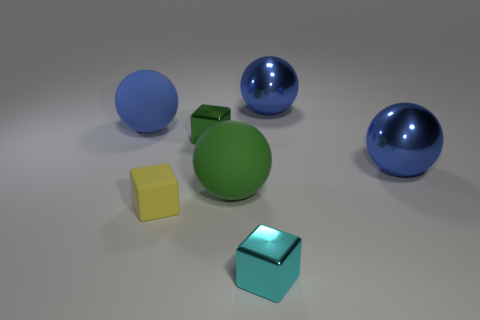There is a blue metallic sphere that is in front of the blue sphere to the left of the cube right of the big green thing; what size is it?
Your answer should be compact. Large. Is the number of green metallic cubes to the right of the small green metal thing greater than the number of tiny cyan blocks?
Make the answer very short. No. Are any tiny cyan metallic things visible?
Ensure brevity in your answer.  Yes. What number of cyan things are the same size as the blue rubber object?
Your response must be concise. 0. Is the number of tiny objects in front of the green metallic object greater than the number of objects that are in front of the cyan cube?
Make the answer very short. Yes. What is the material of the yellow thing that is the same size as the green metallic thing?
Your answer should be very brief. Rubber. The green rubber object has what shape?
Offer a very short reply. Sphere. How many green things are either small objects or large spheres?
Your answer should be compact. 2. There is a cyan block that is the same material as the small green block; what is its size?
Provide a succinct answer. Small. Does the big object left of the green rubber object have the same material as the blue sphere in front of the small green metal block?
Offer a terse response. No. 